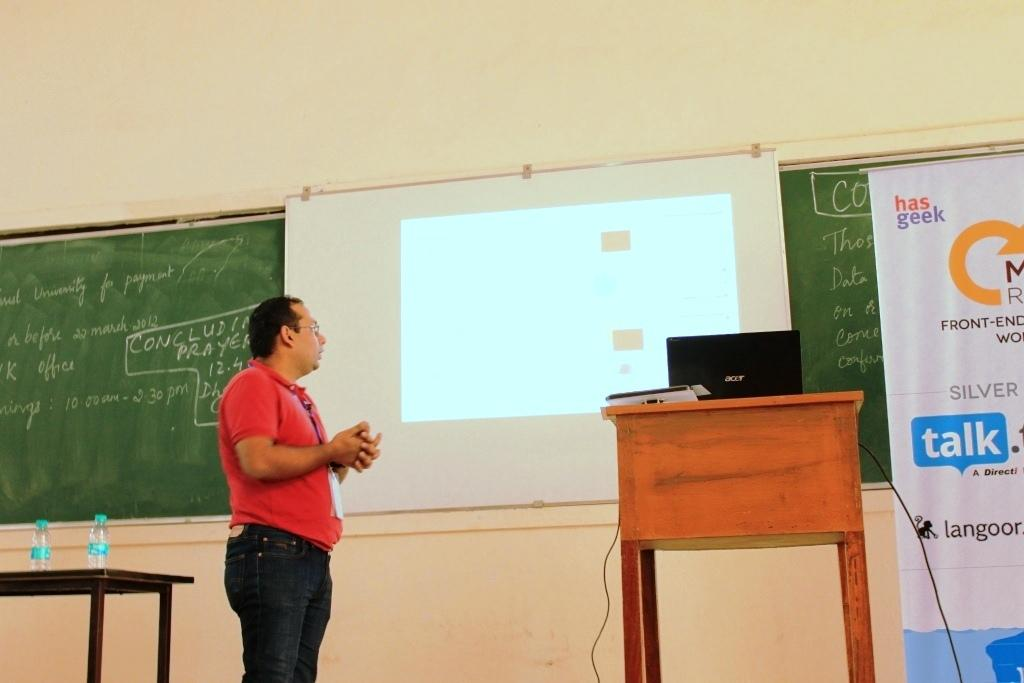What is the person in the image wearing? The person is wearing a red shirt. What is the person doing in the image? The person is standing and looking at a projected image. What color is the board in the image? There is a green board in the image. What is on the table in the image? There is a laptop on the table. Where is the laptop located in relation to the person? The laptop is beside the person. What type of meal is the person eating in the image? There is no meal present in the image; the person is looking at a projected image and standing near a laptop. Can you describe the person's feet in the image? The provided facts do not mention the person's feet, so we cannot describe them. 